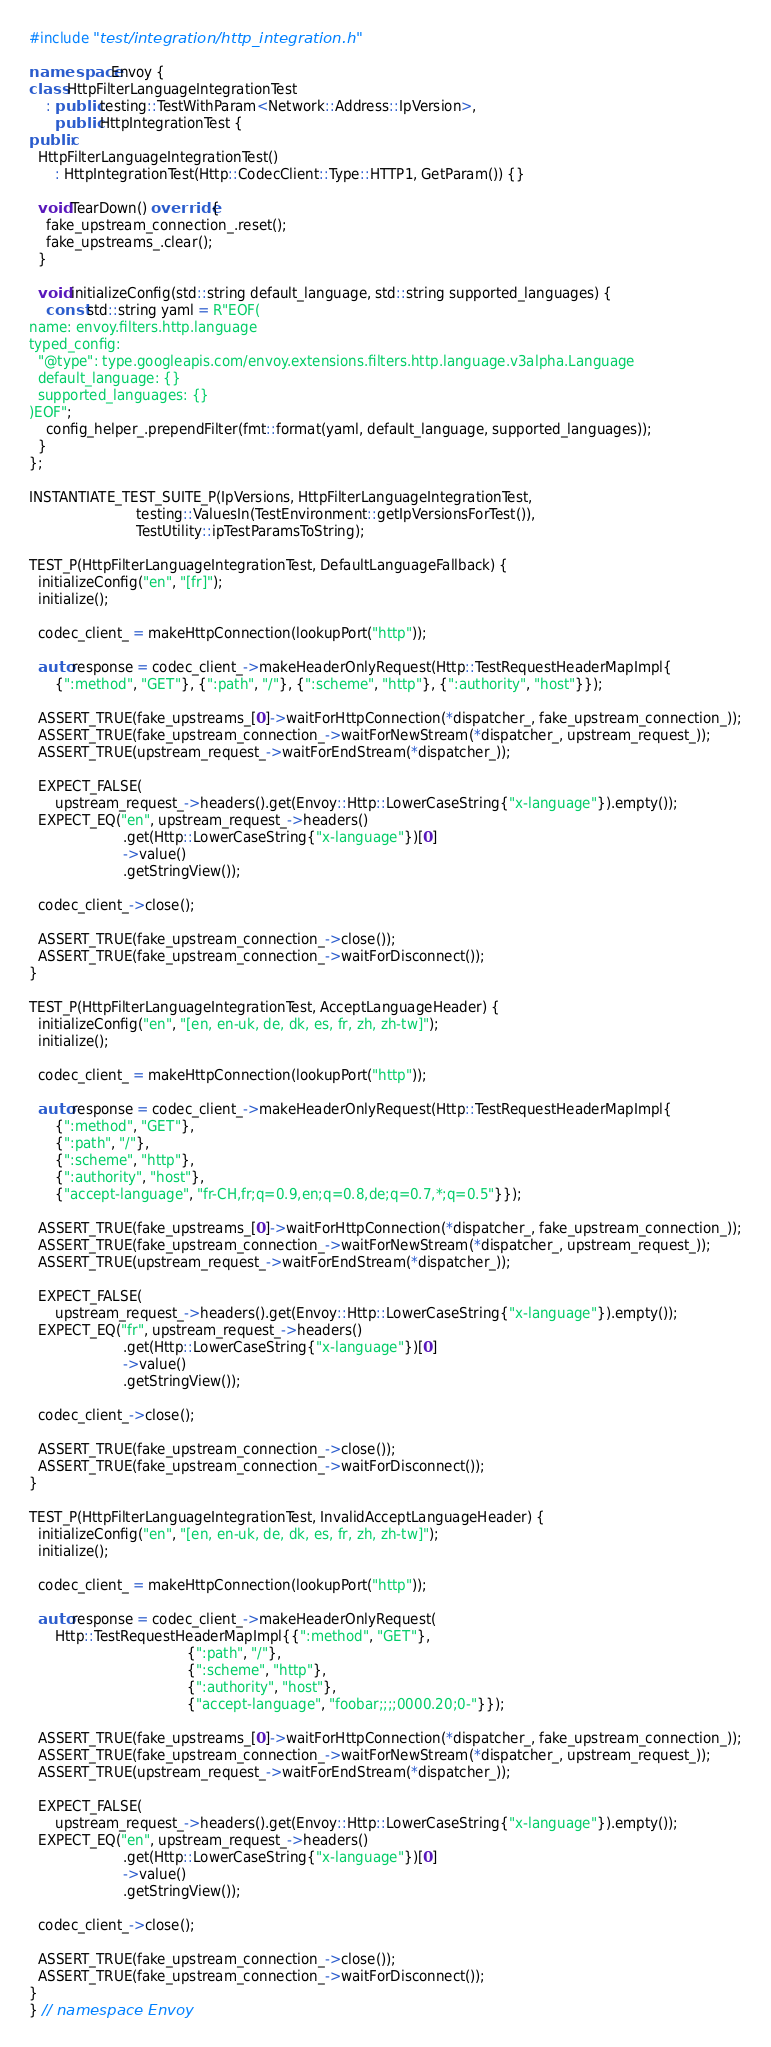<code> <loc_0><loc_0><loc_500><loc_500><_C++_>#include "test/integration/http_integration.h"

namespace Envoy {
class HttpFilterLanguageIntegrationTest
    : public testing::TestWithParam<Network::Address::IpVersion>,
      public HttpIntegrationTest {
public:
  HttpFilterLanguageIntegrationTest()
      : HttpIntegrationTest(Http::CodecClient::Type::HTTP1, GetParam()) {}

  void TearDown() override {
    fake_upstream_connection_.reset();
    fake_upstreams_.clear();
  }

  void initializeConfig(std::string default_language, std::string supported_languages) {
    const std::string yaml = R"EOF(
name: envoy.filters.http.language
typed_config:
  "@type": type.googleapis.com/envoy.extensions.filters.http.language.v3alpha.Language
  default_language: {}
  supported_languages: {}
)EOF";
    config_helper_.prependFilter(fmt::format(yaml, default_language, supported_languages));
  }
};

INSTANTIATE_TEST_SUITE_P(IpVersions, HttpFilterLanguageIntegrationTest,
                         testing::ValuesIn(TestEnvironment::getIpVersionsForTest()),
                         TestUtility::ipTestParamsToString);

TEST_P(HttpFilterLanguageIntegrationTest, DefaultLanguageFallback) {
  initializeConfig("en", "[fr]");
  initialize();

  codec_client_ = makeHttpConnection(lookupPort("http"));

  auto response = codec_client_->makeHeaderOnlyRequest(Http::TestRequestHeaderMapImpl{
      {":method", "GET"}, {":path", "/"}, {":scheme", "http"}, {":authority", "host"}});

  ASSERT_TRUE(fake_upstreams_[0]->waitForHttpConnection(*dispatcher_, fake_upstream_connection_));
  ASSERT_TRUE(fake_upstream_connection_->waitForNewStream(*dispatcher_, upstream_request_));
  ASSERT_TRUE(upstream_request_->waitForEndStream(*dispatcher_));

  EXPECT_FALSE(
      upstream_request_->headers().get(Envoy::Http::LowerCaseString{"x-language"}).empty());
  EXPECT_EQ("en", upstream_request_->headers()
                      .get(Http::LowerCaseString{"x-language"})[0]
                      ->value()
                      .getStringView());

  codec_client_->close();

  ASSERT_TRUE(fake_upstream_connection_->close());
  ASSERT_TRUE(fake_upstream_connection_->waitForDisconnect());
}

TEST_P(HttpFilterLanguageIntegrationTest, AcceptLanguageHeader) {
  initializeConfig("en", "[en, en-uk, de, dk, es, fr, zh, zh-tw]");
  initialize();

  codec_client_ = makeHttpConnection(lookupPort("http"));

  auto response = codec_client_->makeHeaderOnlyRequest(Http::TestRequestHeaderMapImpl{
      {":method", "GET"},
      {":path", "/"},
      {":scheme", "http"},
      {":authority", "host"},
      {"accept-language", "fr-CH,fr;q=0.9,en;q=0.8,de;q=0.7,*;q=0.5"}});

  ASSERT_TRUE(fake_upstreams_[0]->waitForHttpConnection(*dispatcher_, fake_upstream_connection_));
  ASSERT_TRUE(fake_upstream_connection_->waitForNewStream(*dispatcher_, upstream_request_));
  ASSERT_TRUE(upstream_request_->waitForEndStream(*dispatcher_));

  EXPECT_FALSE(
      upstream_request_->headers().get(Envoy::Http::LowerCaseString{"x-language"}).empty());
  EXPECT_EQ("fr", upstream_request_->headers()
                      .get(Http::LowerCaseString{"x-language"})[0]
                      ->value()
                      .getStringView());

  codec_client_->close();

  ASSERT_TRUE(fake_upstream_connection_->close());
  ASSERT_TRUE(fake_upstream_connection_->waitForDisconnect());
}

TEST_P(HttpFilterLanguageIntegrationTest, InvalidAcceptLanguageHeader) {
  initializeConfig("en", "[en, en-uk, de, dk, es, fr, zh, zh-tw]");
  initialize();

  codec_client_ = makeHttpConnection(lookupPort("http"));

  auto response = codec_client_->makeHeaderOnlyRequest(
      Http::TestRequestHeaderMapImpl{{":method", "GET"},
                                     {":path", "/"},
                                     {":scheme", "http"},
                                     {":authority", "host"},
                                     {"accept-language", "foobar;;;;0000.20;0-"}});

  ASSERT_TRUE(fake_upstreams_[0]->waitForHttpConnection(*dispatcher_, fake_upstream_connection_));
  ASSERT_TRUE(fake_upstream_connection_->waitForNewStream(*dispatcher_, upstream_request_));
  ASSERT_TRUE(upstream_request_->waitForEndStream(*dispatcher_));

  EXPECT_FALSE(
      upstream_request_->headers().get(Envoy::Http::LowerCaseString{"x-language"}).empty());
  EXPECT_EQ("en", upstream_request_->headers()
                      .get(Http::LowerCaseString{"x-language"})[0]
                      ->value()
                      .getStringView());

  codec_client_->close();

  ASSERT_TRUE(fake_upstream_connection_->close());
  ASSERT_TRUE(fake_upstream_connection_->waitForDisconnect());
}
} // namespace Envoy
</code> 